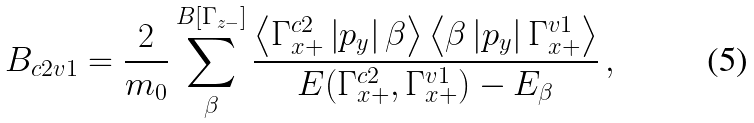Convert formula to latex. <formula><loc_0><loc_0><loc_500><loc_500>B _ { c 2 v 1 } = \frac { 2 } { m _ { 0 } } \sum _ { \beta } ^ { B \left [ \Gamma _ { z - } \right ] } \frac { \left \langle \Gamma _ { x + } ^ { c 2 } \left | p _ { y } \right | \beta \right \rangle \left \langle \beta \left | p _ { y } \right | \Gamma _ { x + } ^ { v 1 } \right \rangle } { E ( \Gamma _ { x + } ^ { c 2 } , \Gamma _ { x + } ^ { v 1 } ) - E _ { \beta } } \, ,</formula> 